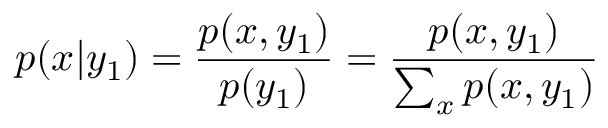<formula> <loc_0><loc_0><loc_500><loc_500>p ( x | y _ { 1 } ) = \frac { p ( x , y _ { 1 } ) } { p ( y _ { 1 } ) } = \frac { p ( x , y _ { 1 } ) } { \sum _ { x } p ( x , y _ { 1 } ) }</formula> 